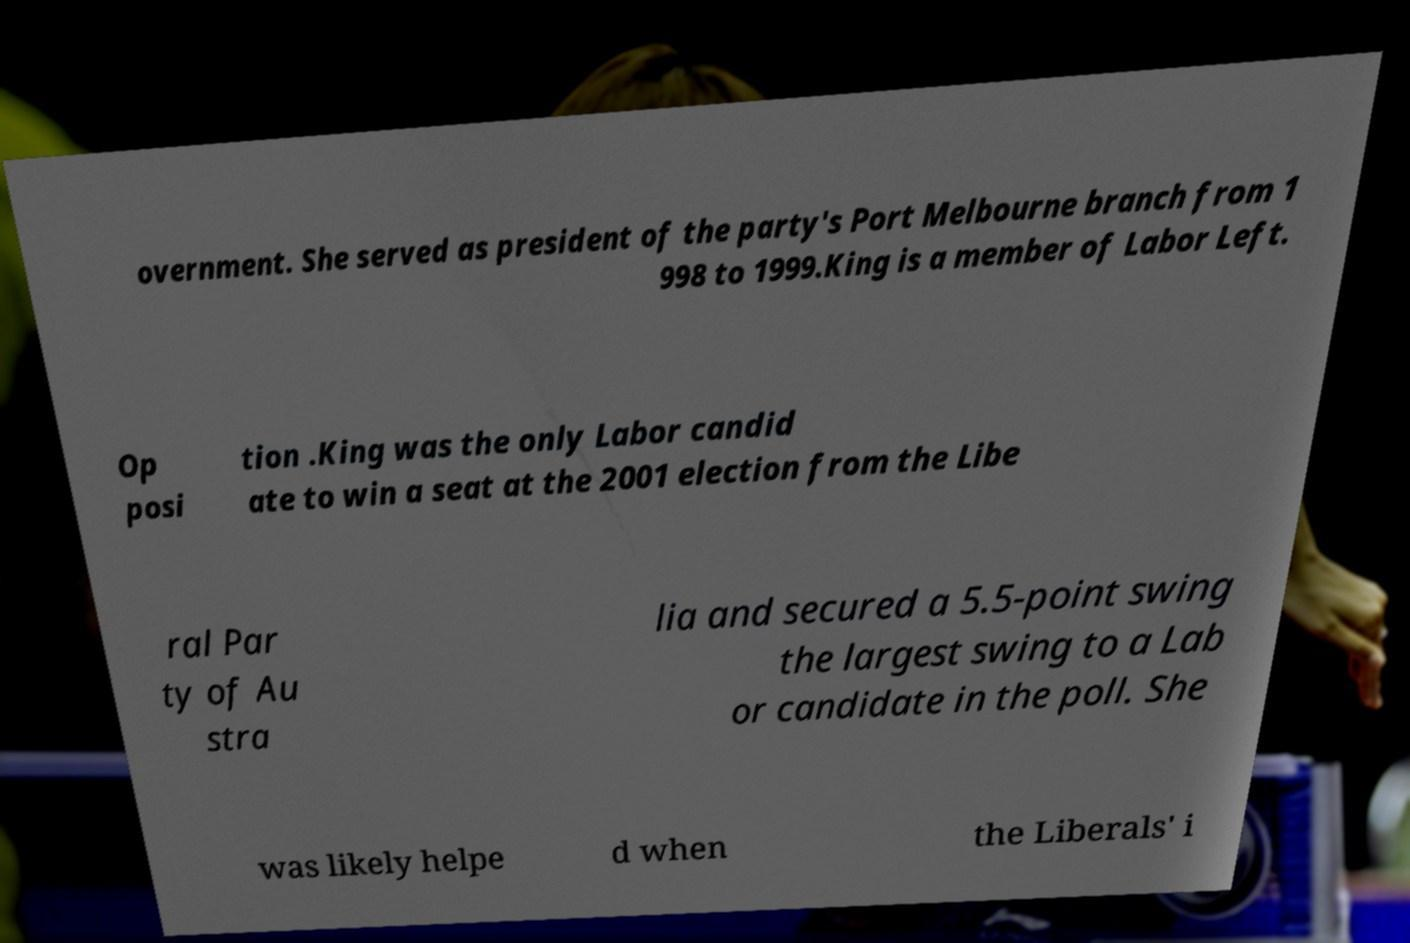Can you accurately transcribe the text from the provided image for me? overnment. She served as president of the party's Port Melbourne branch from 1 998 to 1999.King is a member of Labor Left. Op posi tion .King was the only Labor candid ate to win a seat at the 2001 election from the Libe ral Par ty of Au stra lia and secured a 5.5-point swing the largest swing to a Lab or candidate in the poll. She was likely helpe d when the Liberals' i 